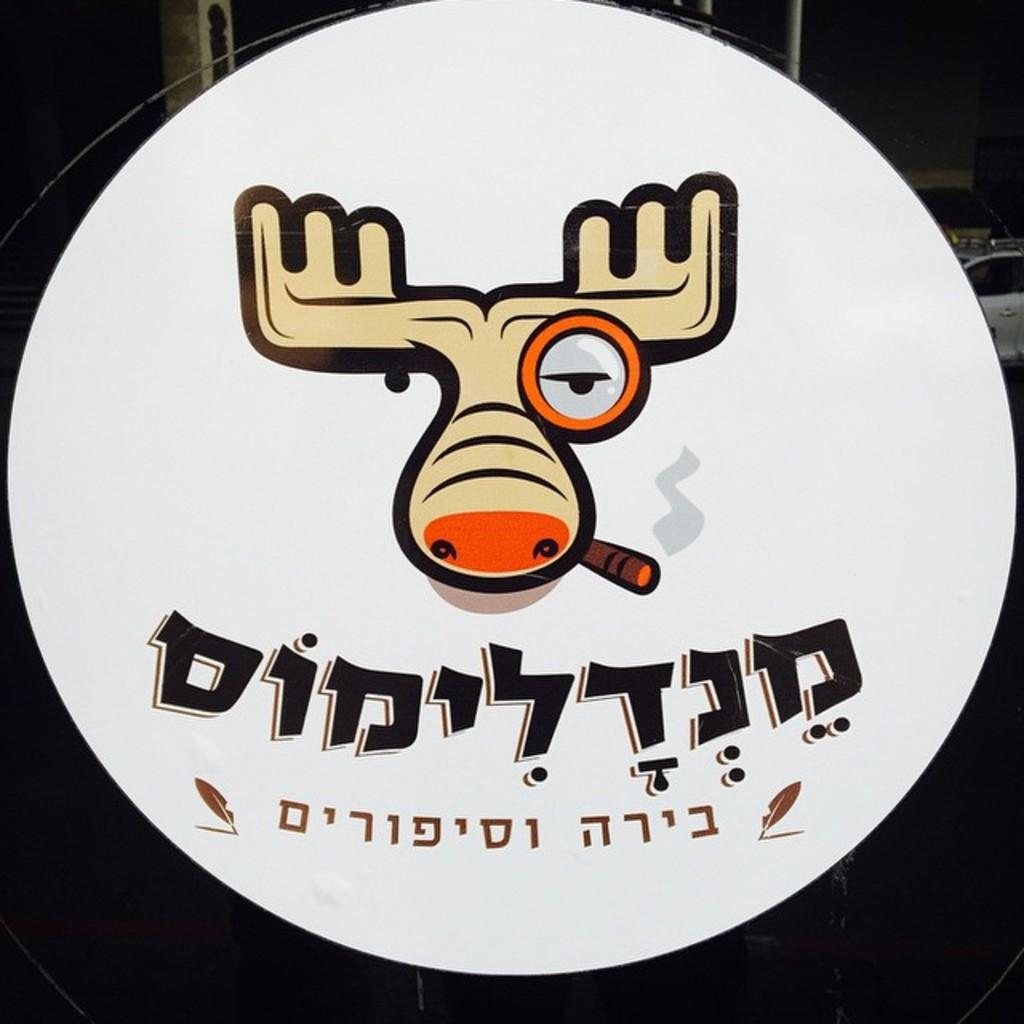What is present in the image that features a design or message? There is a poster in the image. What type of symbol can be seen on the poster? The poster has the symbol of an animal. What else is included on the poster besides the symbol? There is text written on the poster. What can be seen in the background of the image? There is a white car visible in the background of the image. Where is the notebook placed in the image? There is no notebook present in the image. Can you describe the bed in the image? There is no bed present in the image. 